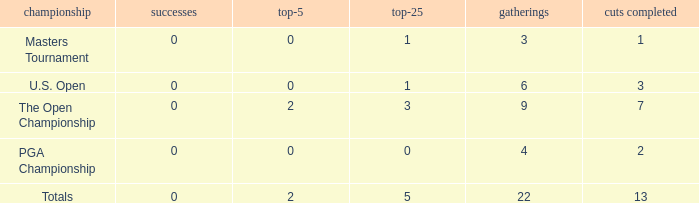What is the average number of cuts made for events with 0 top-5s? None. 